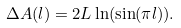<formula> <loc_0><loc_0><loc_500><loc_500>\Delta A ( l ) = 2 L \ln ( \sin ( \pi l ) ) .</formula> 